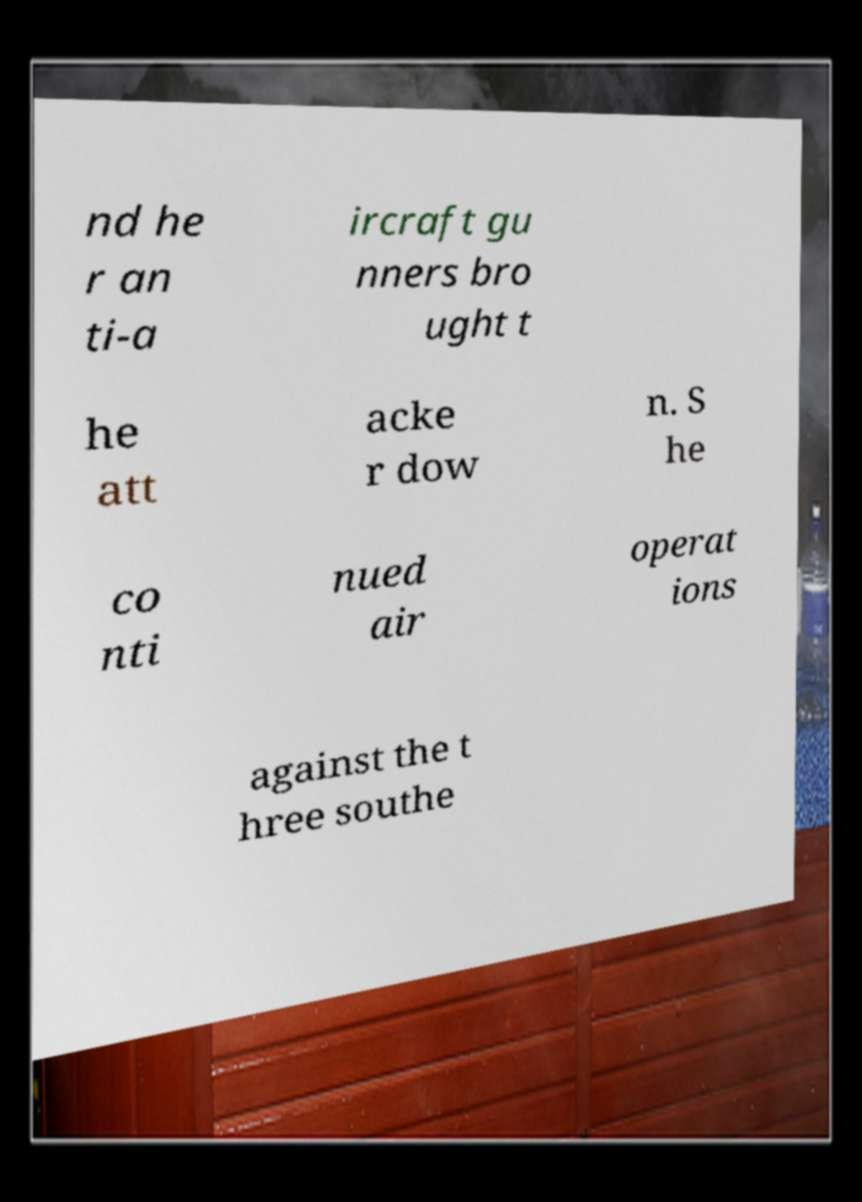Please read and relay the text visible in this image. What does it say? nd he r an ti-a ircraft gu nners bro ught t he att acke r dow n. S he co nti nued air operat ions against the t hree southe 